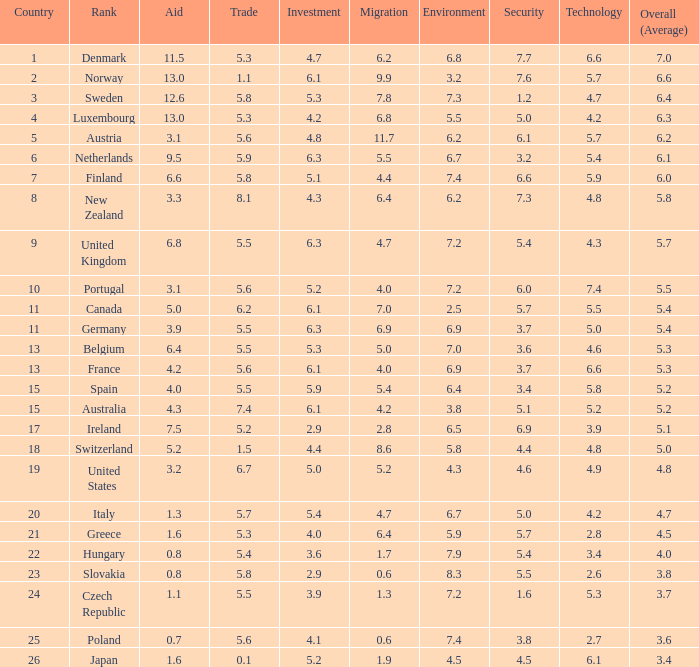What is the migration index when trading is 4.7. 